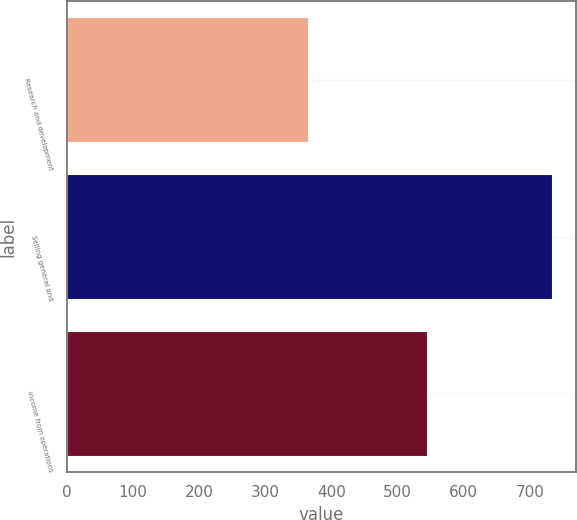Convert chart to OTSL. <chart><loc_0><loc_0><loc_500><loc_500><bar_chart><fcel>Research and development<fcel>Selling general and<fcel>Income from operations<nl><fcel>365<fcel>733<fcel>544<nl></chart> 